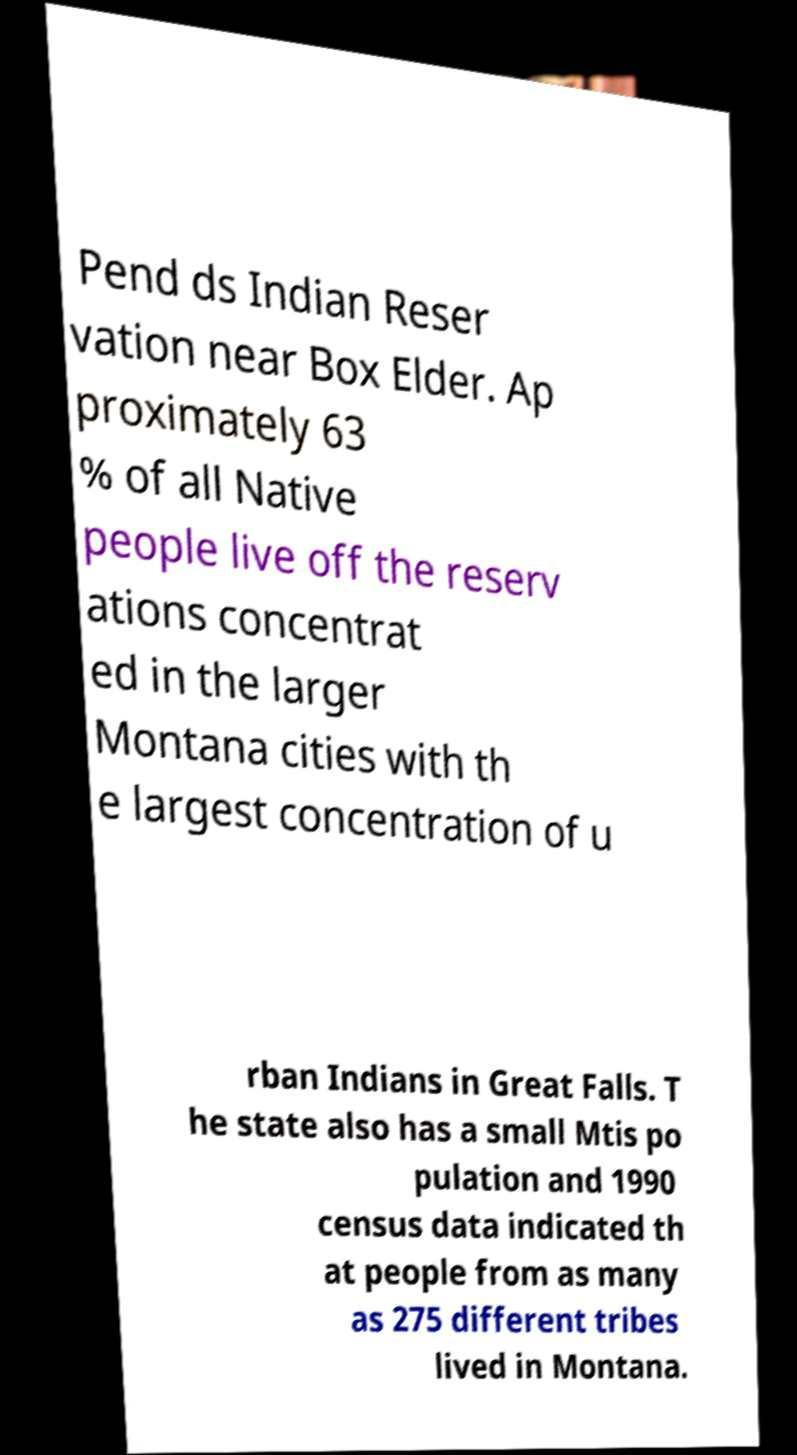Please read and relay the text visible in this image. What does it say? Pend ds Indian Reser vation near Box Elder. Ap proximately 63 % of all Native people live off the reserv ations concentrat ed in the larger Montana cities with th e largest concentration of u rban Indians in Great Falls. T he state also has a small Mtis po pulation and 1990 census data indicated th at people from as many as 275 different tribes lived in Montana. 